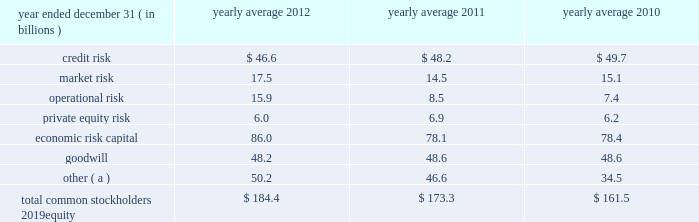Management 2019s discussion and analysis 120 jpmorgan chase & co./2012 annual report $ 12.0 billion , and jpmorgan clearing 2019s net capital was $ 6.6 billion , exceeding the minimum requirement by $ 5.0 billion .
In addition to its minimum net capital requirement , jpmorgan securities is required to hold tentative net capital in excess of $ 1.0 billion and is also required to notify the sec in the event that tentative net capital is less than $ 5.0 billion , in accordance with the market and credit risk standards of appendix e of the net capital rule .
As of december 31 , 2012 , jpmorgan securities had tentative net capital in excess of the minimum and notification requirements .
J.p .
Morgan securities plc ( formerly j.p .
Morgan securities ltd. ) is a wholly-owned subsidiary of jpmorgan chase bank , n.a .
And is the firm 2019s principal operating subsidiary in the u.k .
It has authority to engage in banking , investment banking and broker-dealer activities .
J.p .
Morgan securities plc is regulated by the u.k .
Financial services authority ( 201cfsa 201d ) .
At december 31 , 2012 , it had total capital of $ 20.8 billion , or a total capital ratio of 15.5% ( 15.5 % ) which exceeded the 8% ( 8 % ) well-capitalized standard applicable to it under basel 2.5 .
Economic risk capital jpmorgan chase assesses its capital adequacy relative to the risks underlying its business activities using internal risk-assessment methodologies .
The firm measures economic capital primarily based on four risk factors : credit , market , operational and private equity risk. .
( a ) reflects additional capital required , in the firm 2019s view , to meet its regulatory and debt rating objectives .
Credit risk capital credit risk capital is estimated separately for the wholesale businesses ( cib , cb and am ) and consumer business ( ccb ) .
Credit risk capital for the wholesale credit portfolio is defined in terms of unexpected credit losses , both from defaults and from declines in the value of the portfolio due to credit deterioration , measured over a one-year period at a confidence level consistent with an 201caa 201d credit rating standard .
Unexpected losses are losses in excess of those for which the allowance for credit losses is maintained .
The capital methodology is based on several principal drivers of credit risk : exposure at default ( or loan-equivalent amount ) , default likelihood , credit spreads , loss severity and portfolio correlation .
Credit risk capital for the consumer portfolio is based on product and other relevant risk segmentation .
Actual segment-level default and severity experience are used to estimate unexpected losses for a one-year horizon at a confidence level consistent with an 201caa 201d credit rating standard .
The decrease in credit risk capital in 2012 was driven by consumer portfolio runoff and continued model enhancements to better estimate future stress credit losses in the consumer portfolio .
See credit risk management on pages 134 2013135 of this annual report for more information about these credit risk measures .
Market risk capital the firm calculates market risk capital guided by the principle that capital should reflect the risk of loss in the value of the portfolios and financial instruments caused by adverse movements in market variables , such as interest and foreign exchange rates , credit spreads , and securities and commodities prices , taking into account the liquidity of the financial instruments .
Results from daily var , weekly stress tests , issuer credit spreads and default risk calculations , as well as other factors , are used to determine appropriate capital levels .
Market risk capital is allocated to each business segment based on its risk assessment .
The increase in market risk capital in 2012 was driven by increased risk in the synthetic credit portfolio .
See market risk management on pages 163 2013169 of this annual report for more information about these market risk measures .
Operational risk capital operational risk is the risk of loss resulting from inadequate or failed processes or systems , human factors or external events .
The operational risk capital model is based on actual losses and potential scenario-based losses , with adjustments to the capital calculation to reflect changes in the quality of the control environment .
The increase in operational risk capital in 2012 was primarily due to continued model enhancements to better capture large historical loss events , including mortgage-related litigation costs .
The increases that occurred during 2012 will be fully reflected in average operational risk capital in 2013 .
See operational risk management on pages 175 2013176 of this annual report for more information about operational risk .
Private equity risk capital capital is allocated to privately- and publicly-held securities , third-party fund investments , and commitments in the private equity portfolio , within the corporate/private equity segment , to cover the potential loss associated with a decline in equity markets and related asset devaluations .
In addition to negative market fluctuations , potential losses in private equity investment portfolios can be magnified by liquidity risk. .
Is the three year average credit risk greater than the market risk? 
Computations: greater(table_average(credit risk, none), table_average(market risk, none))
Answer: yes. 